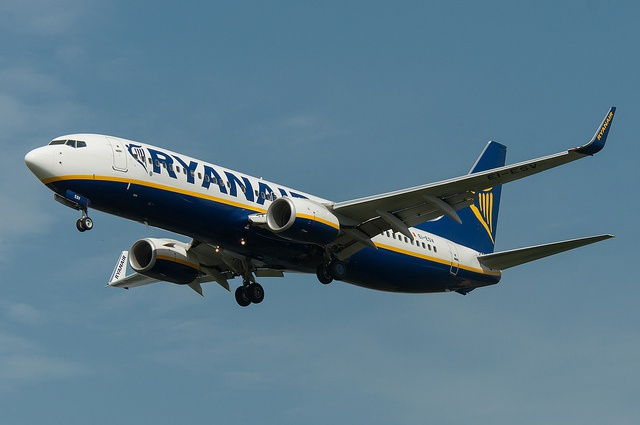Describe the objects in this image and their specific colors. I can see a airplane in gray, black, lightgray, and navy tones in this image. 